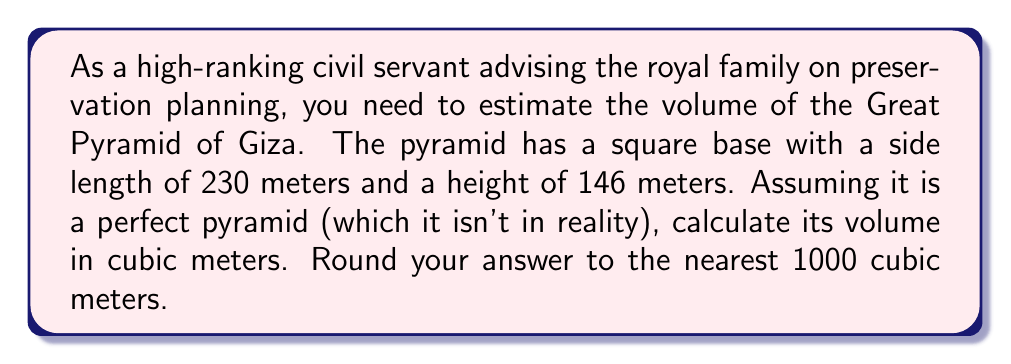Show me your answer to this math problem. To solve this problem, we'll follow these steps:

1) The volume of a pyramid is given by the formula:

   $$V = \frac{1}{3} \times B \times h$$

   Where $V$ is the volume, $B$ is the area of the base, and $h$ is the height.

2) First, let's calculate the area of the base. The base is a square with side length 230 meters:

   $$B = 230 \text{ m} \times 230 \text{ m} = 52,900 \text{ m}^2$$

3) Now we can plug this into our volume formula, along with the height of 146 meters:

   $$V = \frac{1}{3} \times 52,900 \text{ m}^2 \times 146 \text{ m}$$

4) Let's calculate:

   $$V = \frac{1}{3} \times 7,723,400 \text{ m}^3 = 2,574,466.67 \text{ m}^3$$

5) Rounding to the nearest 1000 cubic meters:

   $$V \approx 2,574,000 \text{ m}^3$$

This estimation provides a good approximation for preservation planning purposes, although it's worth noting that the actual Great Pyramid is not a perfect pyramid and has internal chambers, so the real volume would be slightly different.
Answer: $2,574,000 \text{ m}^3$ 